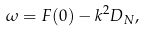Convert formula to latex. <formula><loc_0><loc_0><loc_500><loc_500>\omega = F ( 0 ) - k ^ { 2 } D _ { N } ,</formula> 